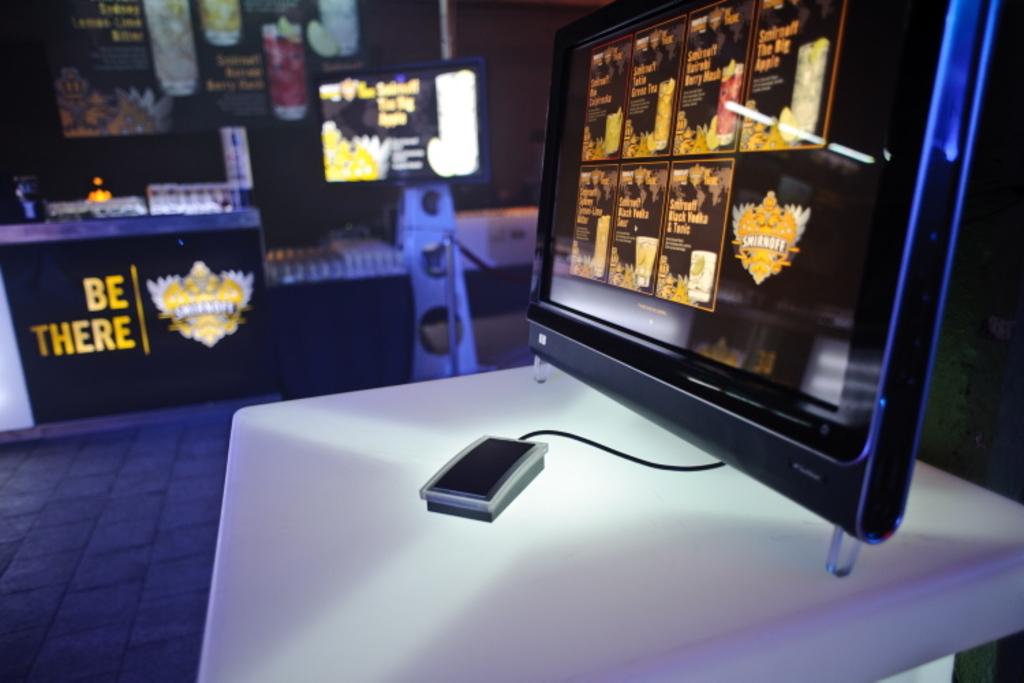Where does the table say it wants you to be?
Your answer should be very brief. There. What does the table say?
Your answer should be very brief. Be there. 